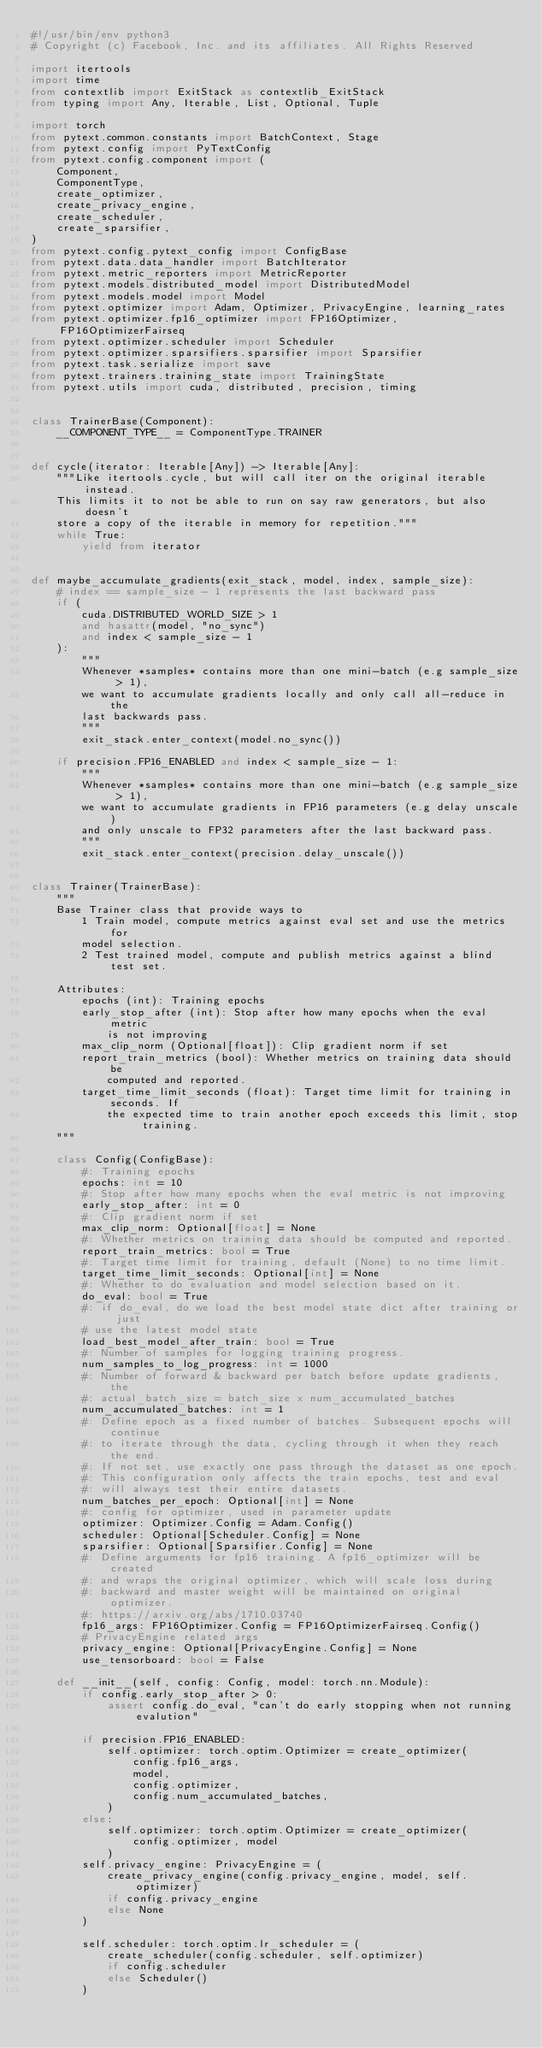<code> <loc_0><loc_0><loc_500><loc_500><_Python_>#!/usr/bin/env python3
# Copyright (c) Facebook, Inc. and its affiliates. All Rights Reserved

import itertools
import time
from contextlib import ExitStack as contextlib_ExitStack
from typing import Any, Iterable, List, Optional, Tuple

import torch
from pytext.common.constants import BatchContext, Stage
from pytext.config import PyTextConfig
from pytext.config.component import (
    Component,
    ComponentType,
    create_optimizer,
    create_privacy_engine,
    create_scheduler,
    create_sparsifier,
)
from pytext.config.pytext_config import ConfigBase
from pytext.data.data_handler import BatchIterator
from pytext.metric_reporters import MetricReporter
from pytext.models.distributed_model import DistributedModel
from pytext.models.model import Model
from pytext.optimizer import Adam, Optimizer, PrivacyEngine, learning_rates
from pytext.optimizer.fp16_optimizer import FP16Optimizer, FP16OptimizerFairseq
from pytext.optimizer.scheduler import Scheduler
from pytext.optimizer.sparsifiers.sparsifier import Sparsifier
from pytext.task.serialize import save
from pytext.trainers.training_state import TrainingState
from pytext.utils import cuda, distributed, precision, timing


class TrainerBase(Component):
    __COMPONENT_TYPE__ = ComponentType.TRAINER


def cycle(iterator: Iterable[Any]) -> Iterable[Any]:
    """Like itertools.cycle, but will call iter on the original iterable instead.
    This limits it to not be able to run on say raw generators, but also doesn't
    store a copy of the iterable in memory for repetition."""
    while True:
        yield from iterator


def maybe_accumulate_gradients(exit_stack, model, index, sample_size):
    # index == sample_size - 1 represents the last backward pass
    if (
        cuda.DISTRIBUTED_WORLD_SIZE > 1
        and hasattr(model, "no_sync")
        and index < sample_size - 1
    ):
        """
        Whenever *samples* contains more than one mini-batch (e.g sample_size > 1),
        we want to accumulate gradients locally and only call all-reduce in the
        last backwards pass.
        """
        exit_stack.enter_context(model.no_sync())

    if precision.FP16_ENABLED and index < sample_size - 1:
        """
        Whenever *samples* contains more than one mini-batch (e.g sample_size > 1),
        we want to accumulate gradients in FP16 parameters (e.g delay unscale)
        and only unscale to FP32 parameters after the last backward pass.
        """
        exit_stack.enter_context(precision.delay_unscale())


class Trainer(TrainerBase):
    """
    Base Trainer class that provide ways to
        1 Train model, compute metrics against eval set and use the metrics for
        model selection.
        2 Test trained model, compute and publish metrics against a blind test set.

    Attributes:
        epochs (int): Training epochs
        early_stop_after (int): Stop after how many epochs when the eval metric
            is not improving
        max_clip_norm (Optional[float]): Clip gradient norm if set
        report_train_metrics (bool): Whether metrics on training data should be
            computed and reported.
        target_time_limit_seconds (float): Target time limit for training in seconds. If
            the expected time to train another epoch exceeds this limit, stop training.
    """

    class Config(ConfigBase):
        #: Training epochs
        epochs: int = 10
        #: Stop after how many epochs when the eval metric is not improving
        early_stop_after: int = 0
        #: Clip gradient norm if set
        max_clip_norm: Optional[float] = None
        #: Whether metrics on training data should be computed and reported.
        report_train_metrics: bool = True
        #: Target time limit for training, default (None) to no time limit.
        target_time_limit_seconds: Optional[int] = None
        #: Whether to do evaluation and model selection based on it.
        do_eval: bool = True
        #: if do_eval, do we load the best model state dict after training or just
        # use the latest model state
        load_best_model_after_train: bool = True
        #: Number of samples for logging training progress.
        num_samples_to_log_progress: int = 1000
        #: Number of forward & backward per batch before update gradients, the
        #: actual_batch_size = batch_size x num_accumulated_batches
        num_accumulated_batches: int = 1
        #: Define epoch as a fixed number of batches. Subsequent epochs will continue
        #: to iterate through the data, cycling through it when they reach the end.
        #: If not set, use exactly one pass through the dataset as one epoch.
        #: This configuration only affects the train epochs, test and eval
        #: will always test their entire datasets.
        num_batches_per_epoch: Optional[int] = None
        #: config for optimizer, used in parameter update
        optimizer: Optimizer.Config = Adam.Config()
        scheduler: Optional[Scheduler.Config] = None
        sparsifier: Optional[Sparsifier.Config] = None
        #: Define arguments for fp16 training. A fp16_optimizer will be created
        #: and wraps the original optimizer, which will scale loss during
        #: backward and master weight will be maintained on original optimizer.
        #: https://arxiv.org/abs/1710.03740
        fp16_args: FP16Optimizer.Config = FP16OptimizerFairseq.Config()
        # PrivacyEngine related args
        privacy_engine: Optional[PrivacyEngine.Config] = None
        use_tensorboard: bool = False

    def __init__(self, config: Config, model: torch.nn.Module):
        if config.early_stop_after > 0:
            assert config.do_eval, "can't do early stopping when not running evalution"

        if precision.FP16_ENABLED:
            self.optimizer: torch.optim.Optimizer = create_optimizer(
                config.fp16_args,
                model,
                config.optimizer,
                config.num_accumulated_batches,
            )
        else:
            self.optimizer: torch.optim.Optimizer = create_optimizer(
                config.optimizer, model
            )
        self.privacy_engine: PrivacyEngine = (
            create_privacy_engine(config.privacy_engine, model, self.optimizer)
            if config.privacy_engine
            else None
        )

        self.scheduler: torch.optim.lr_scheduler = (
            create_scheduler(config.scheduler, self.optimizer)
            if config.scheduler
            else Scheduler()
        )</code> 